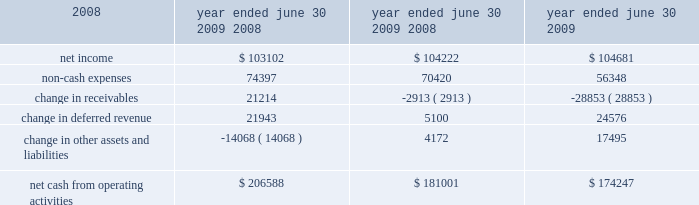26 | 2009 annual report in fiscal 2008 , revenues in the credit union systems and services business segment increased 14% ( 14 % ) from fiscal 2007 .
All revenue components within the segment experienced growth during fiscal 2008 .
License revenue generated the largest dollar growth in revenue as episys ae , our flagship core processing system aimed at larger credit unions , experienced strong sales throughout the year .
Support and service revenue , which is the largest component of total revenues for the credit union segment , experienced 34 percent growth in eft support and 10 percent growth in in-house support .
Gross profit in this business segment increased $ 9344 in fiscal 2008 compared to fiscal 2007 , due primarily to the increase in license revenue , which carries the highest margins .
Liquidity and capital resources we have historically generated positive cash flow from operations and have generally used funds generated from operations and short-term borrowings on our revolving credit facility to meet capital requirements .
We expect this trend to continue in the future .
The company 2019s cash and cash equivalents increased to $ 118251 at june 30 , 2009 from $ 65565 at june 30 , 2008 .
The table summarizes net cash from operating activities in the statement of cash flows : 2009 2008 2007 .
Year ended june 30 , cash provided by operations increased $ 25587 to $ 206588 for the fiscal year ended june 30 , 2009 as compared to $ 181001 for the fiscal year ended june 30 , 2008 .
This increase is primarily attributable to a decrease in receivables compared to the same period a year ago of $ 21214 .
This decrease is largely the result of fiscal 2010 annual software maintenance billings being provided to customers earlier than in the prior year , which allowed more cash to be collected before the end of the fiscal year than in previous years .
Further , we collected more cash overall related to revenues that will be recognized in subsequent periods in the current year than in fiscal 2008 .
Cash used in investing activities for the fiscal year ended june 2009 was $ 59227 and includes $ 3027 in contingent consideration paid on prior years 2019 acquisitions .
Cash used in investing activities for the fiscal year ended june 2008 was $ 102148 and includes payments for acquisitions of $ 48109 , plus $ 1215 in contingent consideration paid on prior years 2019 acquisitions .
Capital expenditures for fiscal 2009 were $ 31562 compared to $ 31105 for fiscal 2008 .
Cash used for software development in fiscal 2009 was $ 24684 compared to $ 23736 during the prior year .
Net cash used in financing activities for the current fiscal year was $ 94675 and includes the repurchase of 3106 shares of our common stock for $ 58405 , the payment of dividends of $ 26903 and $ 13489 net repayment on our revolving credit facilities .
Cash used in financing activities was partially offset by proceeds of $ 3773 from the exercise of stock options and the sale of common stock ( through the employee stock purchase plan ) and $ 348 excess tax benefits from stock option exercises .
During fiscal 2008 , net cash used in financing activities for the fiscal year was $ 101905 and includes the repurchase of 4200 shares of our common stock for $ 100996 , the payment of dividends of $ 24683 and $ 429 net repayment on our revolving credit facilities .
Cash used in financing activities was partially offset by proceeds of $ 20394 from the exercise of stock options and the sale of common stock and $ 3809 excess tax benefits from stock option exercises .
Beginning during fiscal 2008 , us financial markets and many of the largest us financial institutions have been shaken by negative developments in the home mortgage industry and the mortgage markets , and particularly the markets for subprime mortgage-backed securities .
Since that time , these and other such developments have resulted in a broad , global economic downturn .
While we , as is the case with most companies , have experienced the effects of this downturn , we have not experienced any significant issues with our current collection efforts , and we believe that any future impact to our liquidity will be minimized by cash generated by recurring sources of revenue and due to our access to available lines of credit. .
Of the cash used in investing activities for the fiscal year ended june 2009 , what percentage was from contingent consideration paid on prior years 2019 acquisitions? 
Computations: (3027 / 59227)
Answer: 0.05111. 